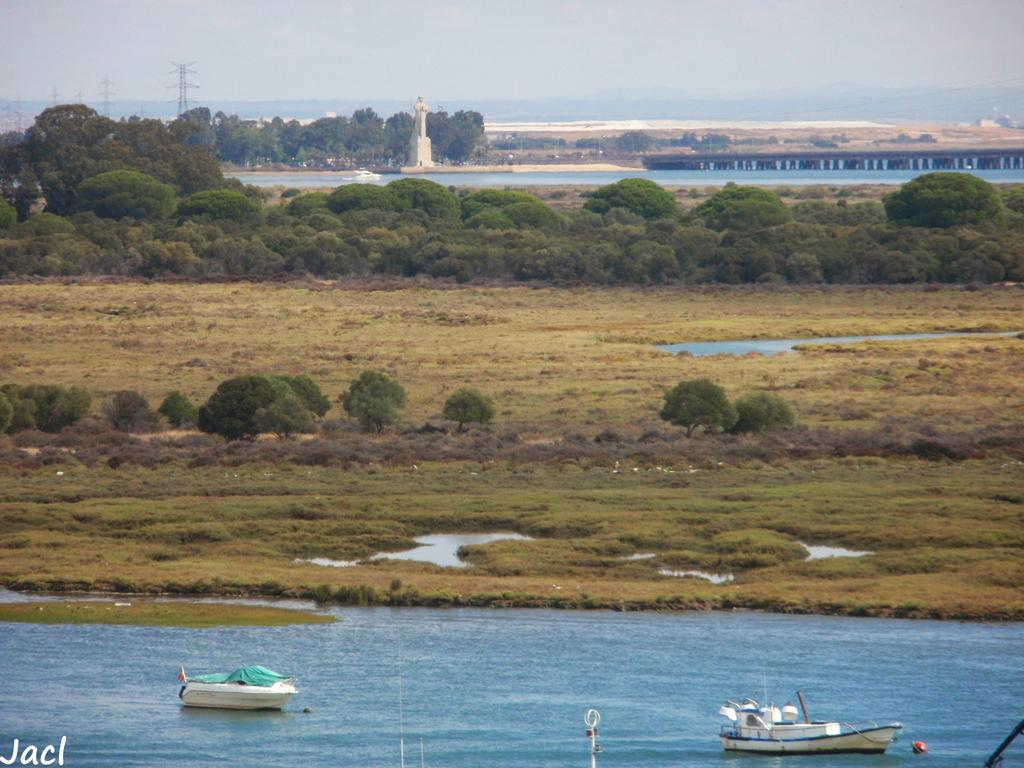What is on the water in the image? There are boats on the water in the image. What structures can be seen in the image? There are towers in the image. What type of vegetation is present in the image? There are trees in the image. What connects the two sides in the image? There is a bridge in the image. What is visible in the background of the image? The sky is visible in the background of the image. Can you see a rabbit wearing a vest in the image? There is no rabbit wearing a vest present in the image. What type of machine is operating on the bridge in the image? There is no machine present in the image; it features boats, towers, trees, a bridge, and the sky. 